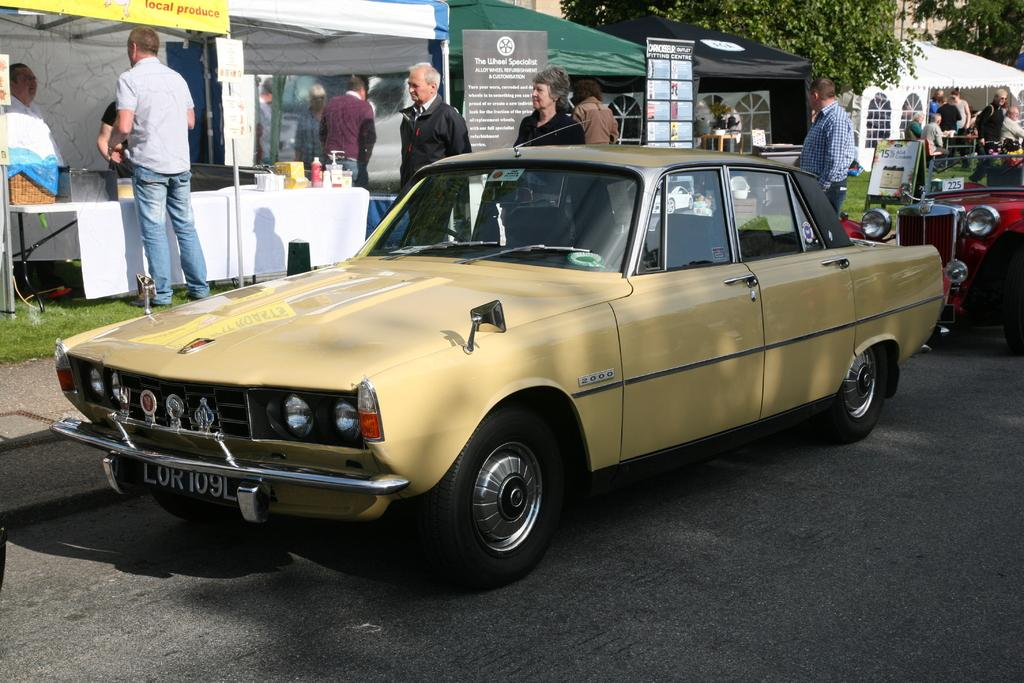What is the main subject of the image? There is a car in the image. What is the setting of the image? There is a road in the image. Can you describe the person in the image? There is a person standing in the image. What type of temporary shelters can be seen in the image? There are tents in the image. What type of vegetation is present in the image? There are trees in the image. What additional object can be seen in the image? There is a banner in the image. What objects are on the table in the image? There are objects on a table in the image. What is the income of the person standing in the image? There is no information about the person's income in the image. Can you see a hammer in the image? There is no hammer present in the image. 